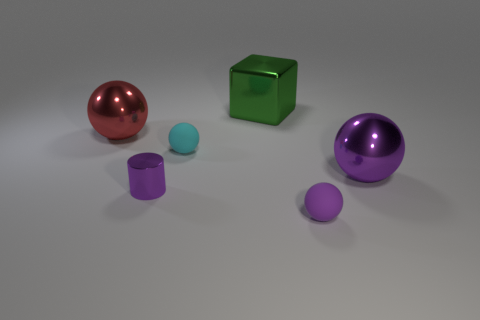Is there any pattern in terms of size or color among the objects? While there's no strict pattern, the objects seem to be arranged with larger objects to the left and gradually smaller objects as we move to the right, representing a variety of colors from red to purple to green. 